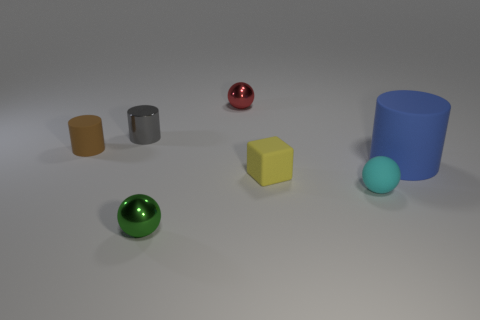Add 3 small rubber blocks. How many objects exist? 10 Subtract all tiny metallic cylinders. How many cylinders are left? 2 Subtract all cylinders. How many objects are left? 4 Subtract 1 cubes. How many cubes are left? 0 Subtract all blue blocks. Subtract all yellow spheres. How many blocks are left? 1 Subtract all tiny red matte cylinders. Subtract all tiny shiny balls. How many objects are left? 5 Add 5 tiny yellow blocks. How many tiny yellow blocks are left? 6 Add 4 big gray cylinders. How many big gray cylinders exist? 4 Subtract all green balls. How many balls are left? 2 Subtract 0 blue blocks. How many objects are left? 7 